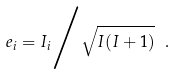<formula> <loc_0><loc_0><loc_500><loc_500>e _ { i } = { I _ { i } } \Big / { \sqrt { I ( I + 1 ) } } \ .</formula> 